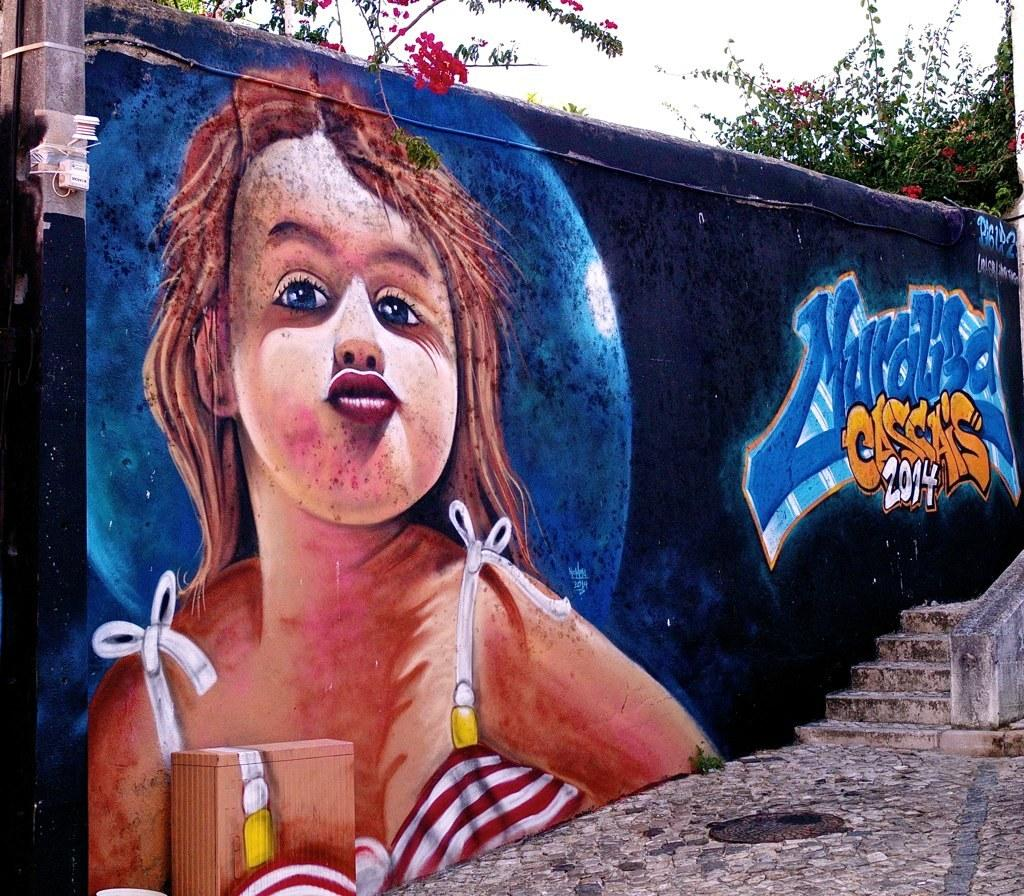What type of artwork is visible on the wall in the image? There is wall graffiti in the image. What architectural feature is located on the right side of the image? There is a staircase on the right side of the image. What object is present on the left side of the image? There is a pole on the left side of the image. What type of vegetation can be seen in the background of the image? There are trees in the background of the image. What is visible at the top of the image? The sky is visible at the top of the image. How much was the payment for the rake in the image? There is no payment or rake present in the image. What type of drain is visible in the image? There is no drain present in the image. 